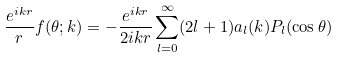<formula> <loc_0><loc_0><loc_500><loc_500>\frac { e ^ { i k r } } { r } f ( \theta ; k ) = - \frac { e ^ { i k r } } { 2 i k r } \sum _ { l = 0 } ^ { \infty } ( 2 l + 1 ) a _ { l } ( k ) P _ { l } ( \cos \theta )</formula> 